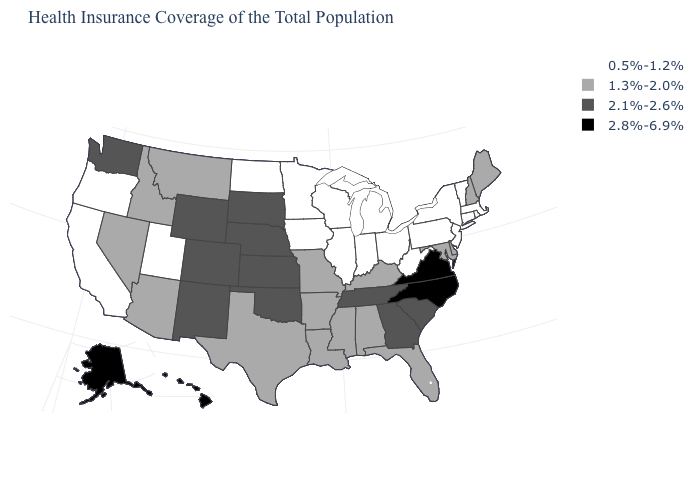Among the states that border Virginia , which have the lowest value?
Short answer required. West Virginia. What is the value of Arizona?
Concise answer only. 1.3%-2.0%. How many symbols are there in the legend?
Concise answer only. 4. Does Idaho have the same value as Louisiana?
Concise answer only. Yes. What is the value of Maine?
Write a very short answer. 1.3%-2.0%. Does Louisiana have a lower value than Florida?
Keep it brief. No. Name the states that have a value in the range 0.5%-1.2%?
Write a very short answer. California, Connecticut, Illinois, Indiana, Iowa, Massachusetts, Michigan, Minnesota, New Jersey, New York, North Dakota, Ohio, Oregon, Pennsylvania, Rhode Island, Utah, Vermont, West Virginia, Wisconsin. Does New Hampshire have the highest value in the USA?
Be succinct. No. Is the legend a continuous bar?
Answer briefly. No. What is the lowest value in states that border Georgia?
Quick response, please. 1.3%-2.0%. What is the value of North Dakota?
Concise answer only. 0.5%-1.2%. Among the states that border Oklahoma , which have the lowest value?
Quick response, please. Arkansas, Missouri, Texas. Is the legend a continuous bar?
Keep it brief. No. Among the states that border Georgia , which have the lowest value?
Give a very brief answer. Alabama, Florida. Name the states that have a value in the range 0.5%-1.2%?
Give a very brief answer. California, Connecticut, Illinois, Indiana, Iowa, Massachusetts, Michigan, Minnesota, New Jersey, New York, North Dakota, Ohio, Oregon, Pennsylvania, Rhode Island, Utah, Vermont, West Virginia, Wisconsin. 